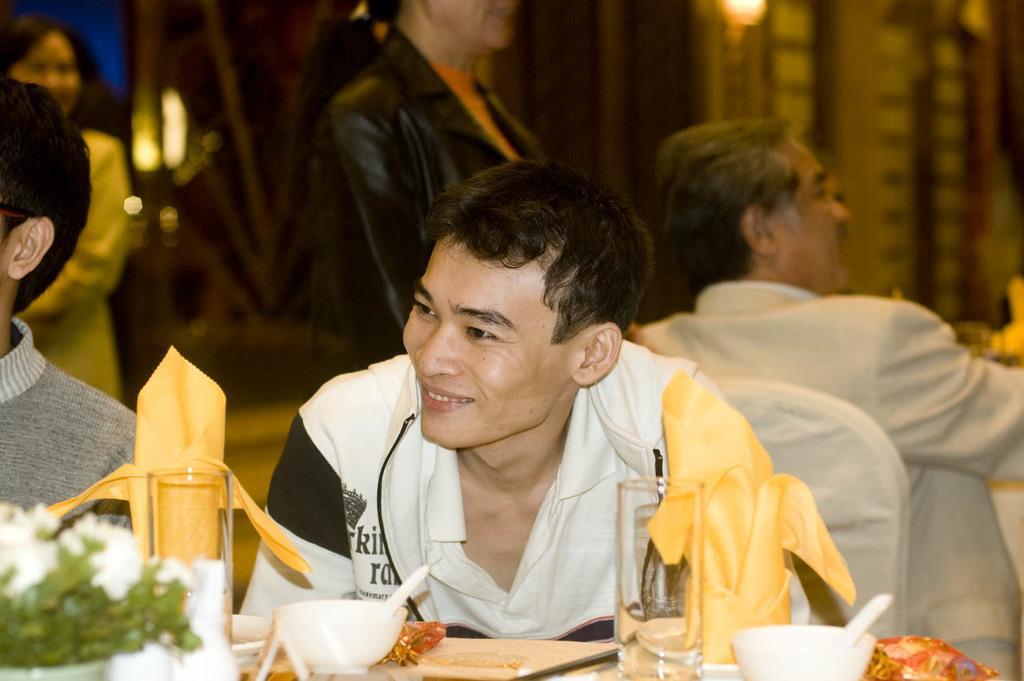Please provide a concise description of this image. In this I can see three people sitting and two people standing and the person sitting in the center of the image is having a food bowl and glasses and some other objects on the table in front of him.  